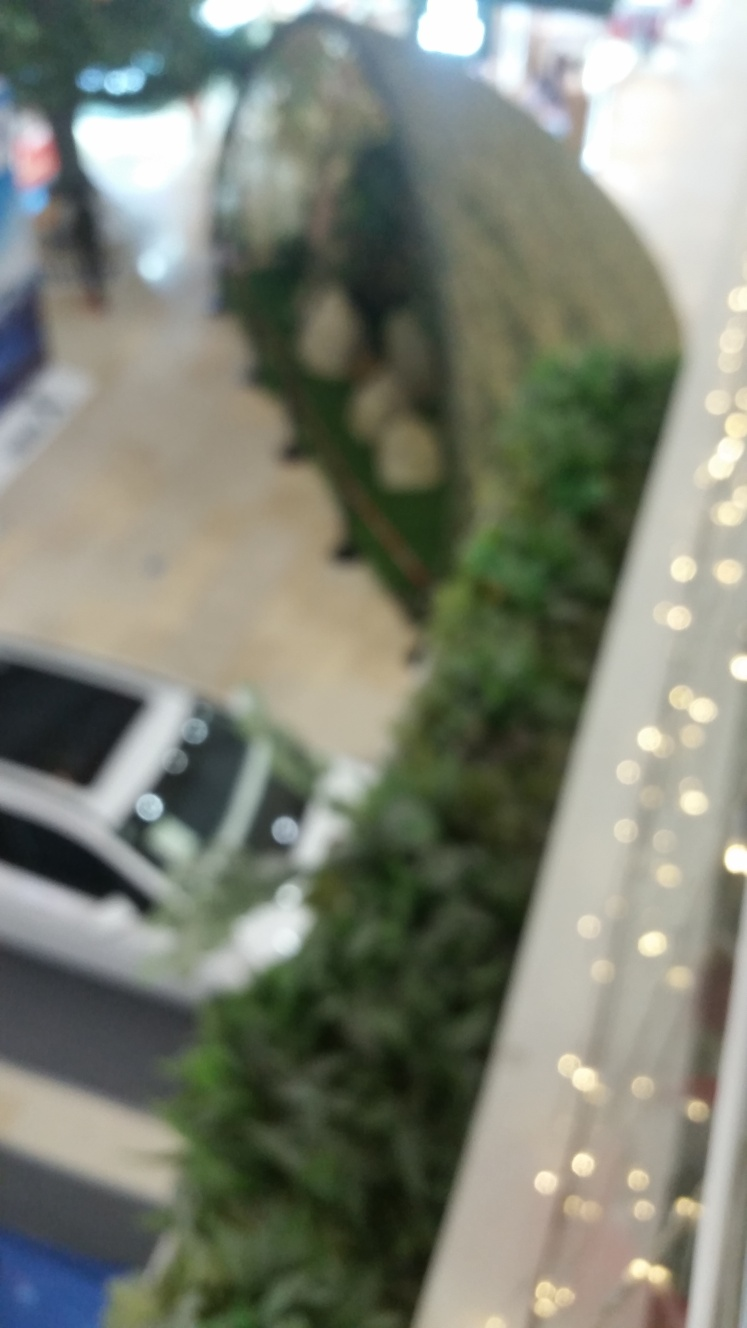Is the perspective overhead in the photo?
A. Yes
B. No
Answer with the option's letter from the given choices directly.
 A. 